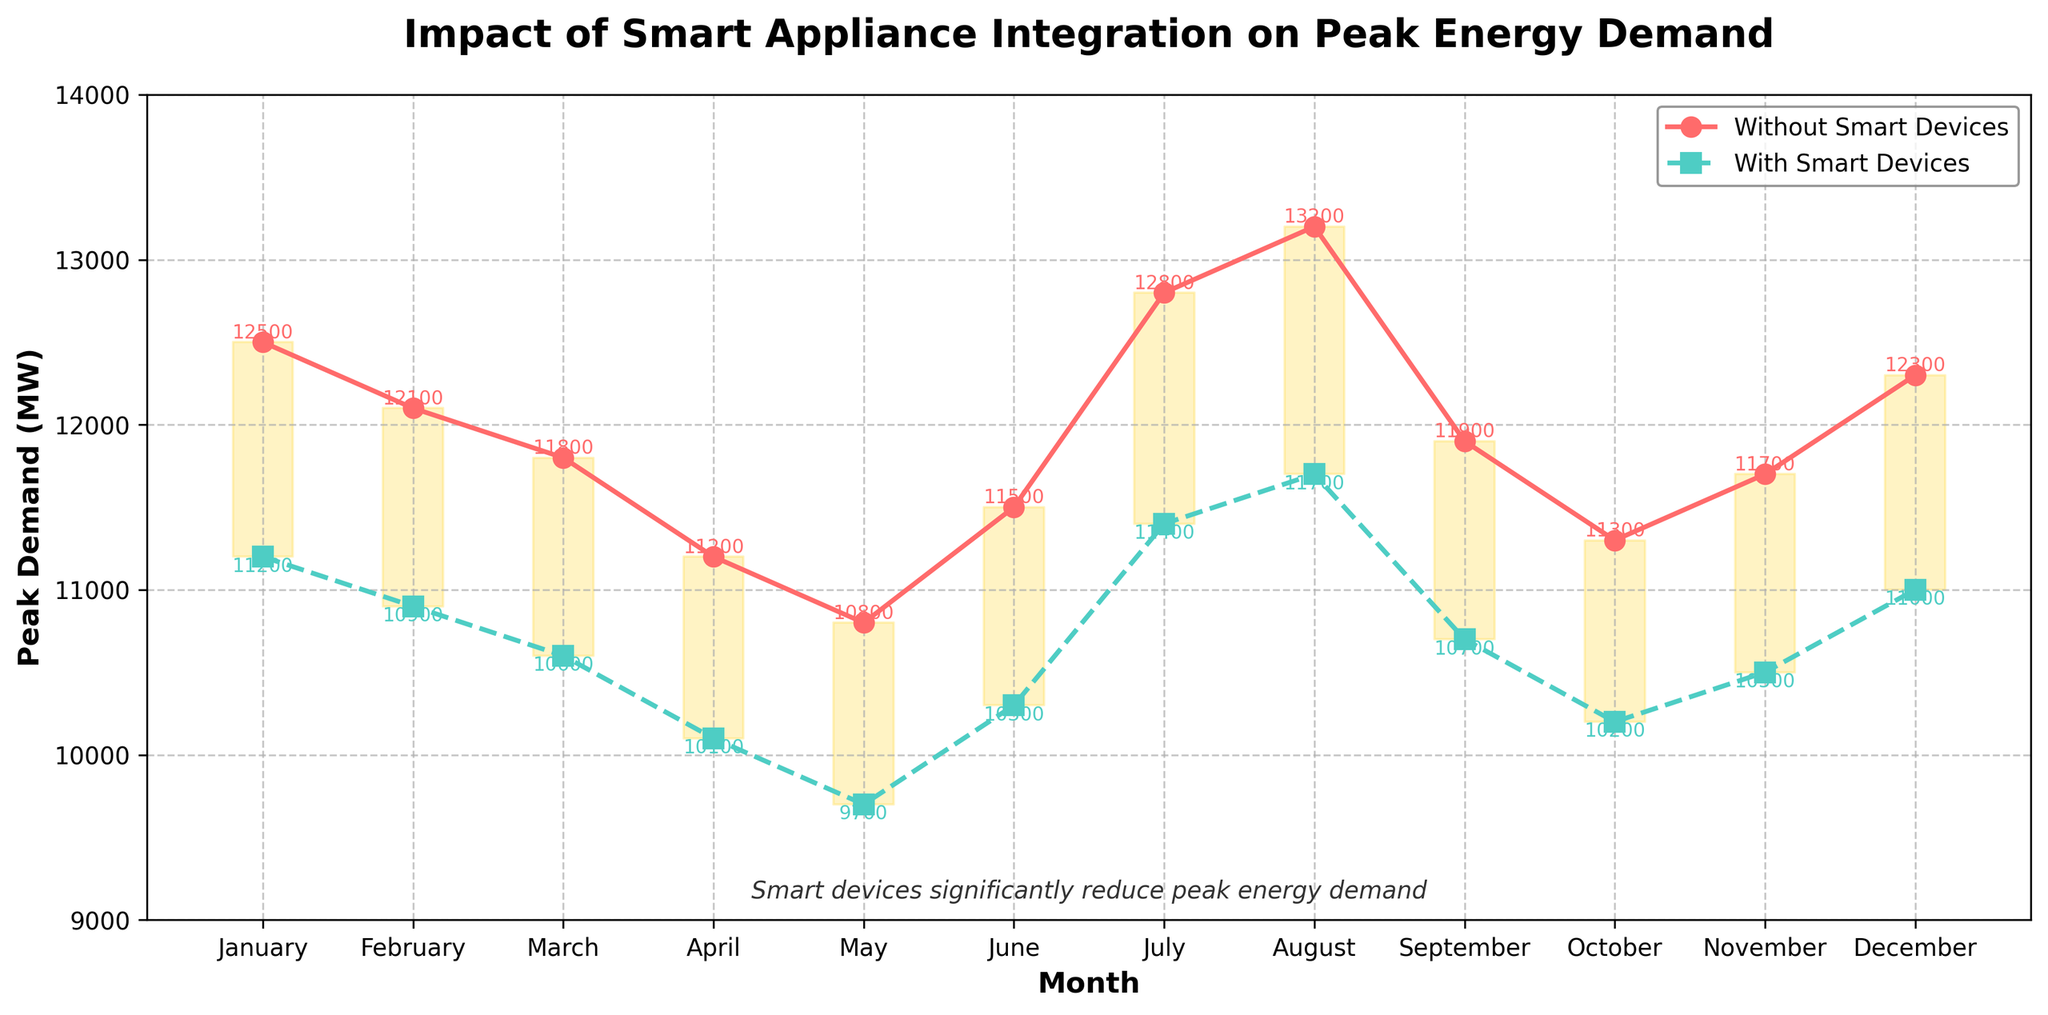What is the difference in peak demand without smart devices and with smart devices in July? To find the difference, subtract the peak demand with smart devices from the peak demand without smart devices for July. Peak demand without smart devices in July is 12800 MW, and with smart devices, it is 11400 MW. So, the difference is 12800 - 11400 = 1400 MW.
Answer: 1400 MW During which month is the reduction in peak demand the highest when using smart devices? To determine the month with the highest reduction, compare the differences between the peak demand without and with smart devices for each month. The largest difference is in August, where the reduction is 13200 MW (without) - 11700 MW (with) = 1500 MW.
Answer: August What is the average peak demand without smart devices throughout the year? The average peak demand without smart devices is calculated by summing up the peak demands for each month and dividing by 12. (12500 + 12100 + 11800 + 11200 + 10800 + 11500 + 12800 + 13200 + 11900 + 11300 + 11700 + 12300) / 12 = 124100 / 12 = 10341.67 MW.
Answer: 10341.67 MW Which months show a peak demand with smart devices above 11000 MW? By examining the plot, we see that the months where the peak demand with smart devices is above 11000 MW are January (11200 MW), July (11400 MW), August (11700 MW), and December (11000 MW).
Answer: January, July, August, December Is the peak demand reduction consistent throughout the year? Observe the differences in peak demand between without and with smart devices for each month. While most months show consistent reduction, some months like August (1500 MW) and October (1100 MW) have higher reductions, indicating some variability in the reduction.
Answer: No What is the total reduction in peak demand across the entire year due to smart devices? To find the total reduction, sum up the monthly differences between peak demand without and with smart devices. (12500 - 11200) + (12100 - 10900) + (11800 - 10600) + (11200 - 10100) + (10800 - 9700) + (11500 - 10300) + (12800 - 11400) + (13200 - 11700) + (11900 - 10700) + (11300 - 10200) + (11700 - 10500) + (12300 - 11000) = 10800 MW.
Answer: 10800 MW What is the range of peak demand without smart devices? The range is found by subtracting the minimum peak demand value from the maximum. The maximum peak demand without smart devices is 13200 MW (August) and the minimum is 10800 MW (May). Thus, the range is 13200 - 10800 = 2400 MW.
Answer: 2400 MW Which month shows the smallest reduction in peak demand due to smart devices? To determine this, identify the month with the smallest difference between without and with smart devices. June has the smallest reduction, where the peak demand without smart devices is 11500 MW and with smart devices is 10300 MW. The difference is 11500 - 10300 = 1200 MW.
Answer: June 